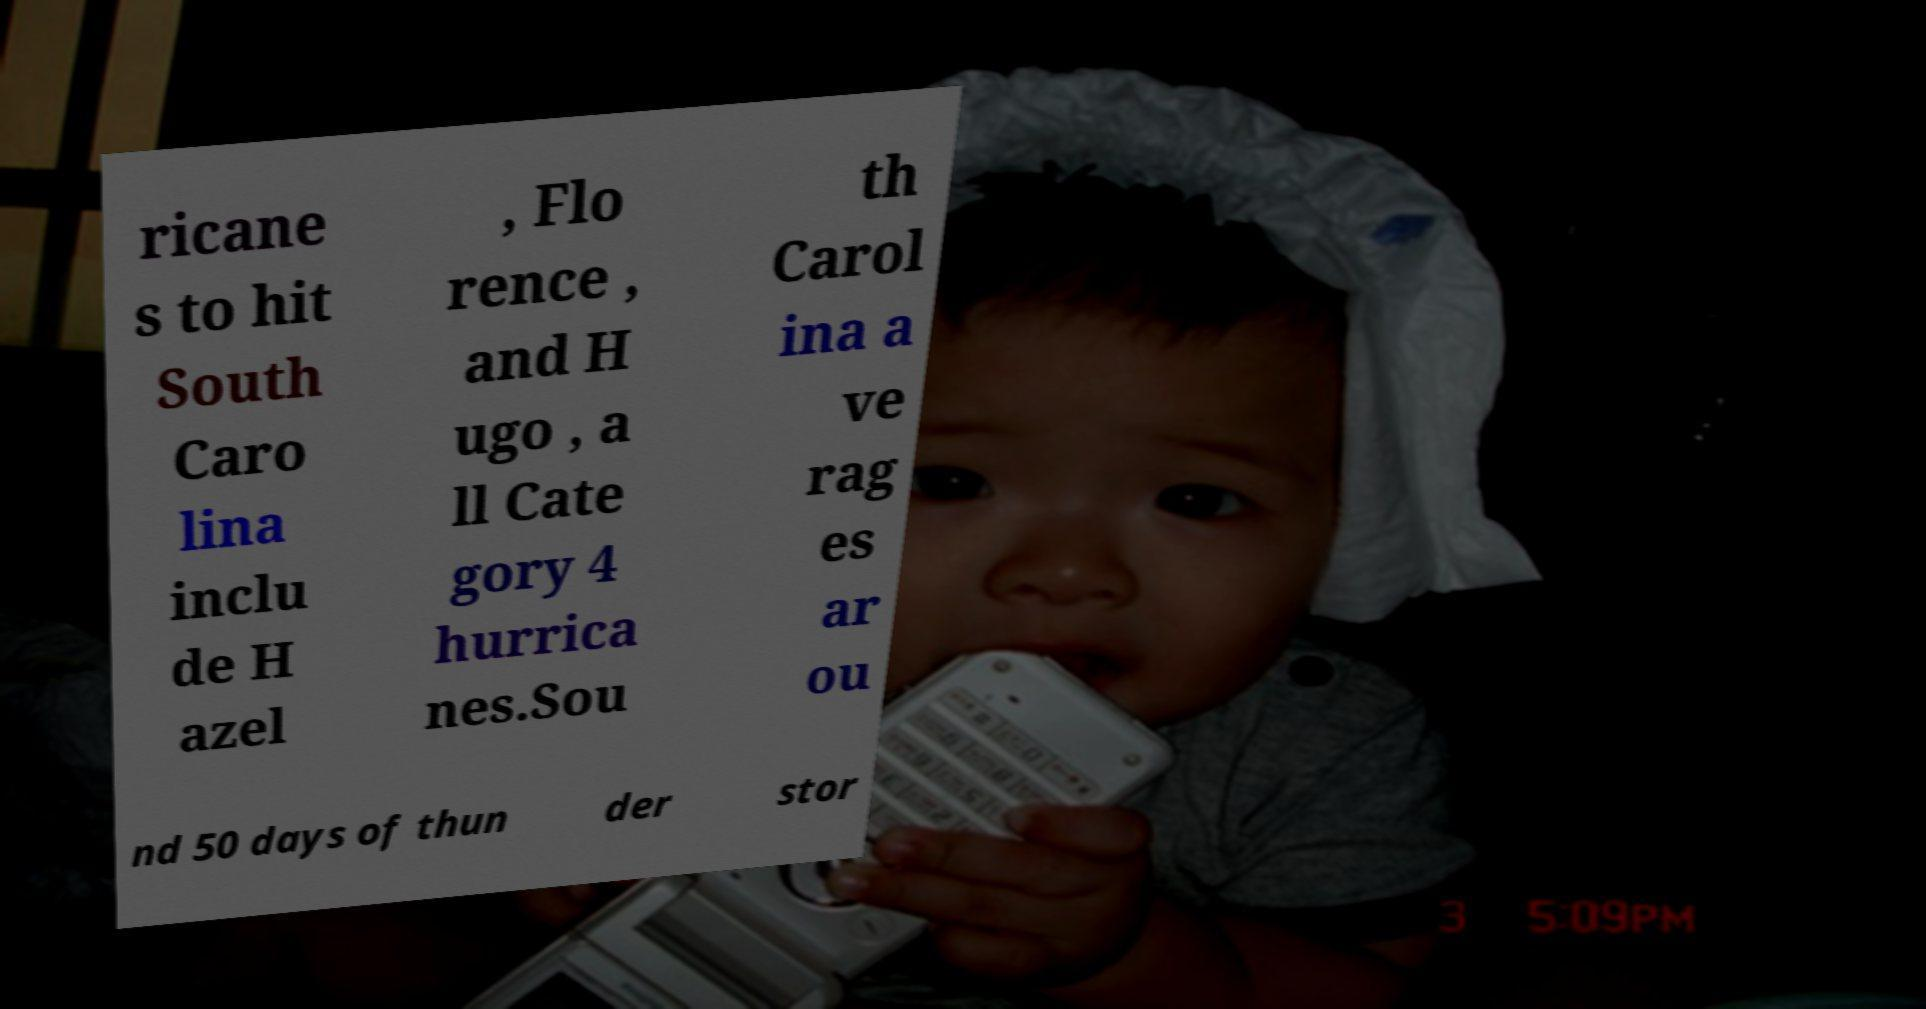What messages or text are displayed in this image? I need them in a readable, typed format. ricane s to hit South Caro lina inclu de H azel , Flo rence , and H ugo , a ll Cate gory 4 hurrica nes.Sou th Carol ina a ve rag es ar ou nd 50 days of thun der stor 